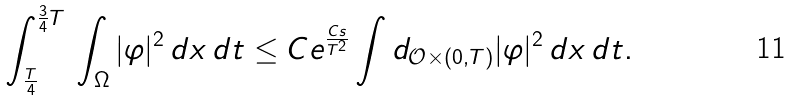<formula> <loc_0><loc_0><loc_500><loc_500>\int _ { \frac { T } { 4 } } ^ { \frac { 3 } { 4 } T } \, \int _ { \Omega } | \varphi | ^ { 2 } \, d x \, d t \leq C e ^ { \frac { C s } { T ^ { 2 } } } \int d _ { \mathcal { O } \times ( 0 , T ) } | \varphi | ^ { 2 } \, d x \, d t .</formula> 